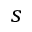Convert formula to latex. <formula><loc_0><loc_0><loc_500><loc_500>s</formula> 